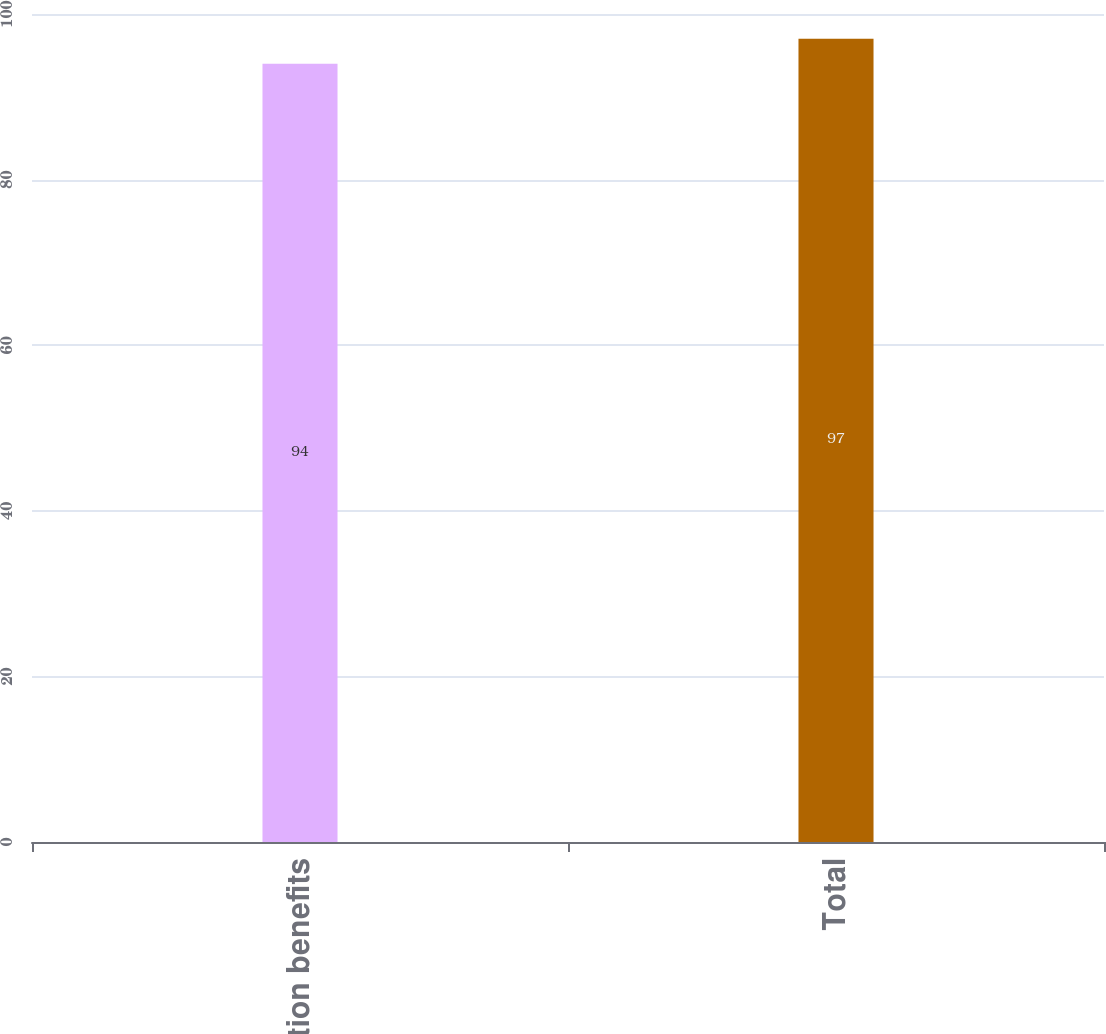Convert chart. <chart><loc_0><loc_0><loc_500><loc_500><bar_chart><fcel>Termination benefits<fcel>Total<nl><fcel>94<fcel>97<nl></chart> 